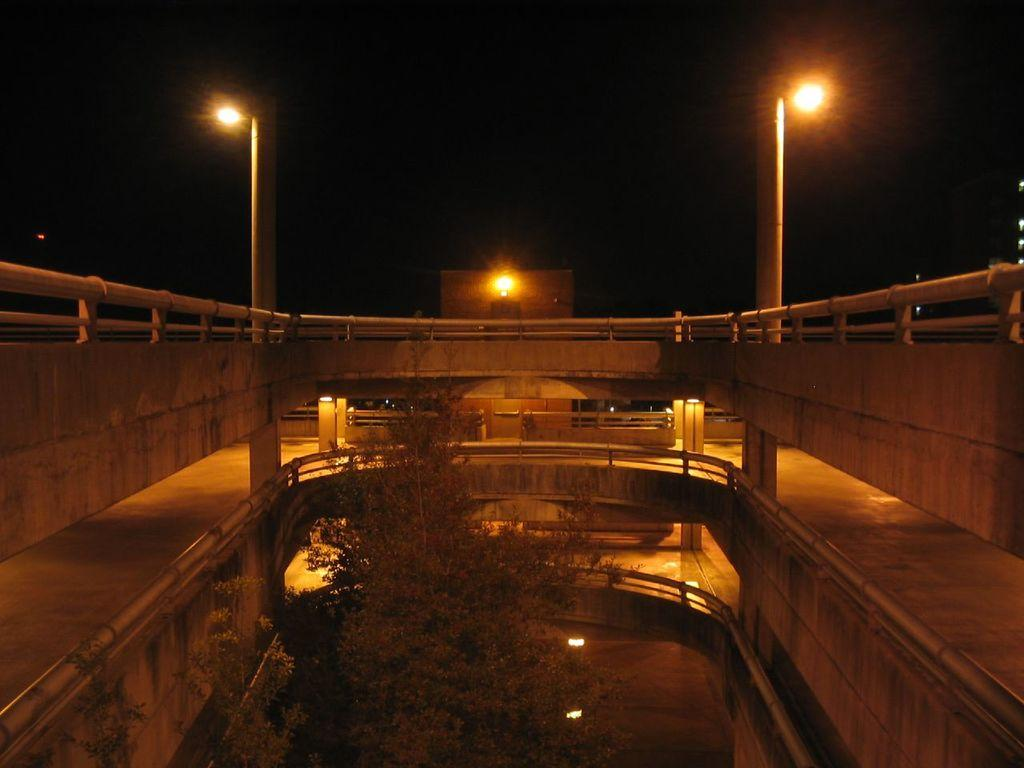What type of structure is depicted in the image? There is a building in the image that resembles a parking garage. Are there any visible sources of illumination in the image? Yes, there are lights visible in the image. What can be seen in the middle of the image? There is a tree in the middle of the image. What is visible at the top of the image? The sky is visible at the top of the image. Can you see your uncle fishing by the river in the image? There is no uncle, fishing, or river present in the image. 